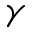<formula> <loc_0><loc_0><loc_500><loc_500>\gamma</formula> 